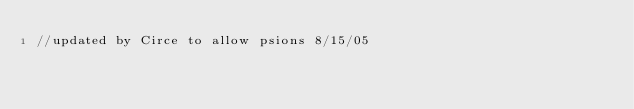<code> <loc_0><loc_0><loc_500><loc_500><_C_>//updated by Circe to allow psions 8/15/05</code> 